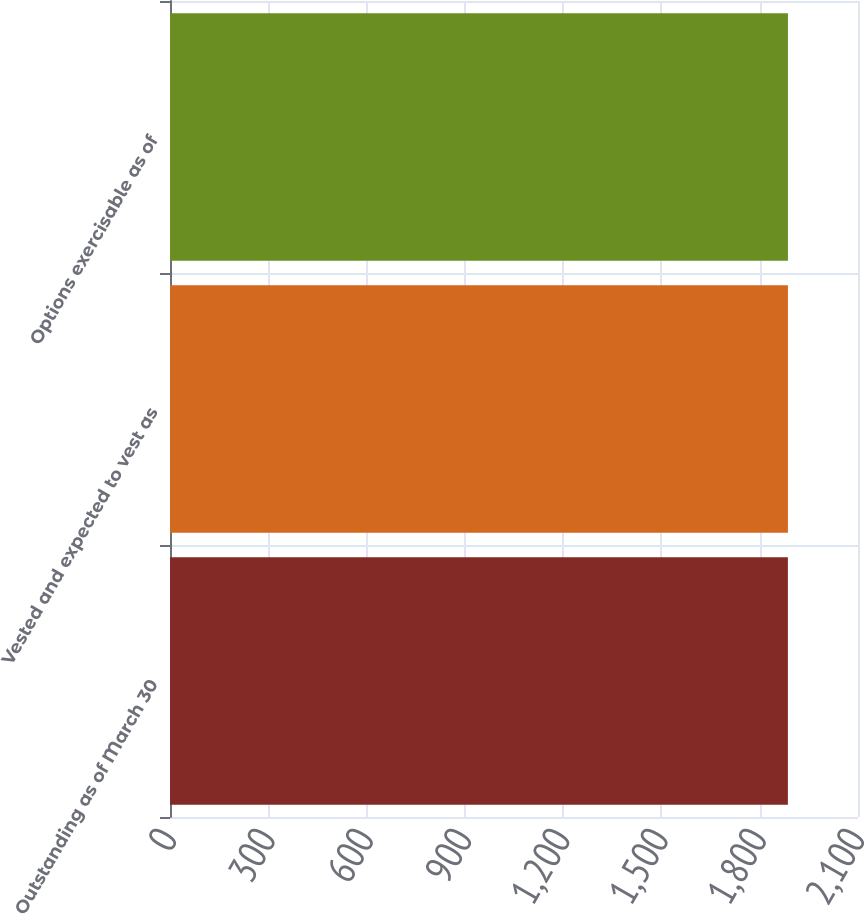Convert chart. <chart><loc_0><loc_0><loc_500><loc_500><bar_chart><fcel>Outstanding as of March 30<fcel>Vested and expected to vest as<fcel>Options exercisable as of<nl><fcel>1886<fcel>1886.1<fcel>1886.2<nl></chart> 